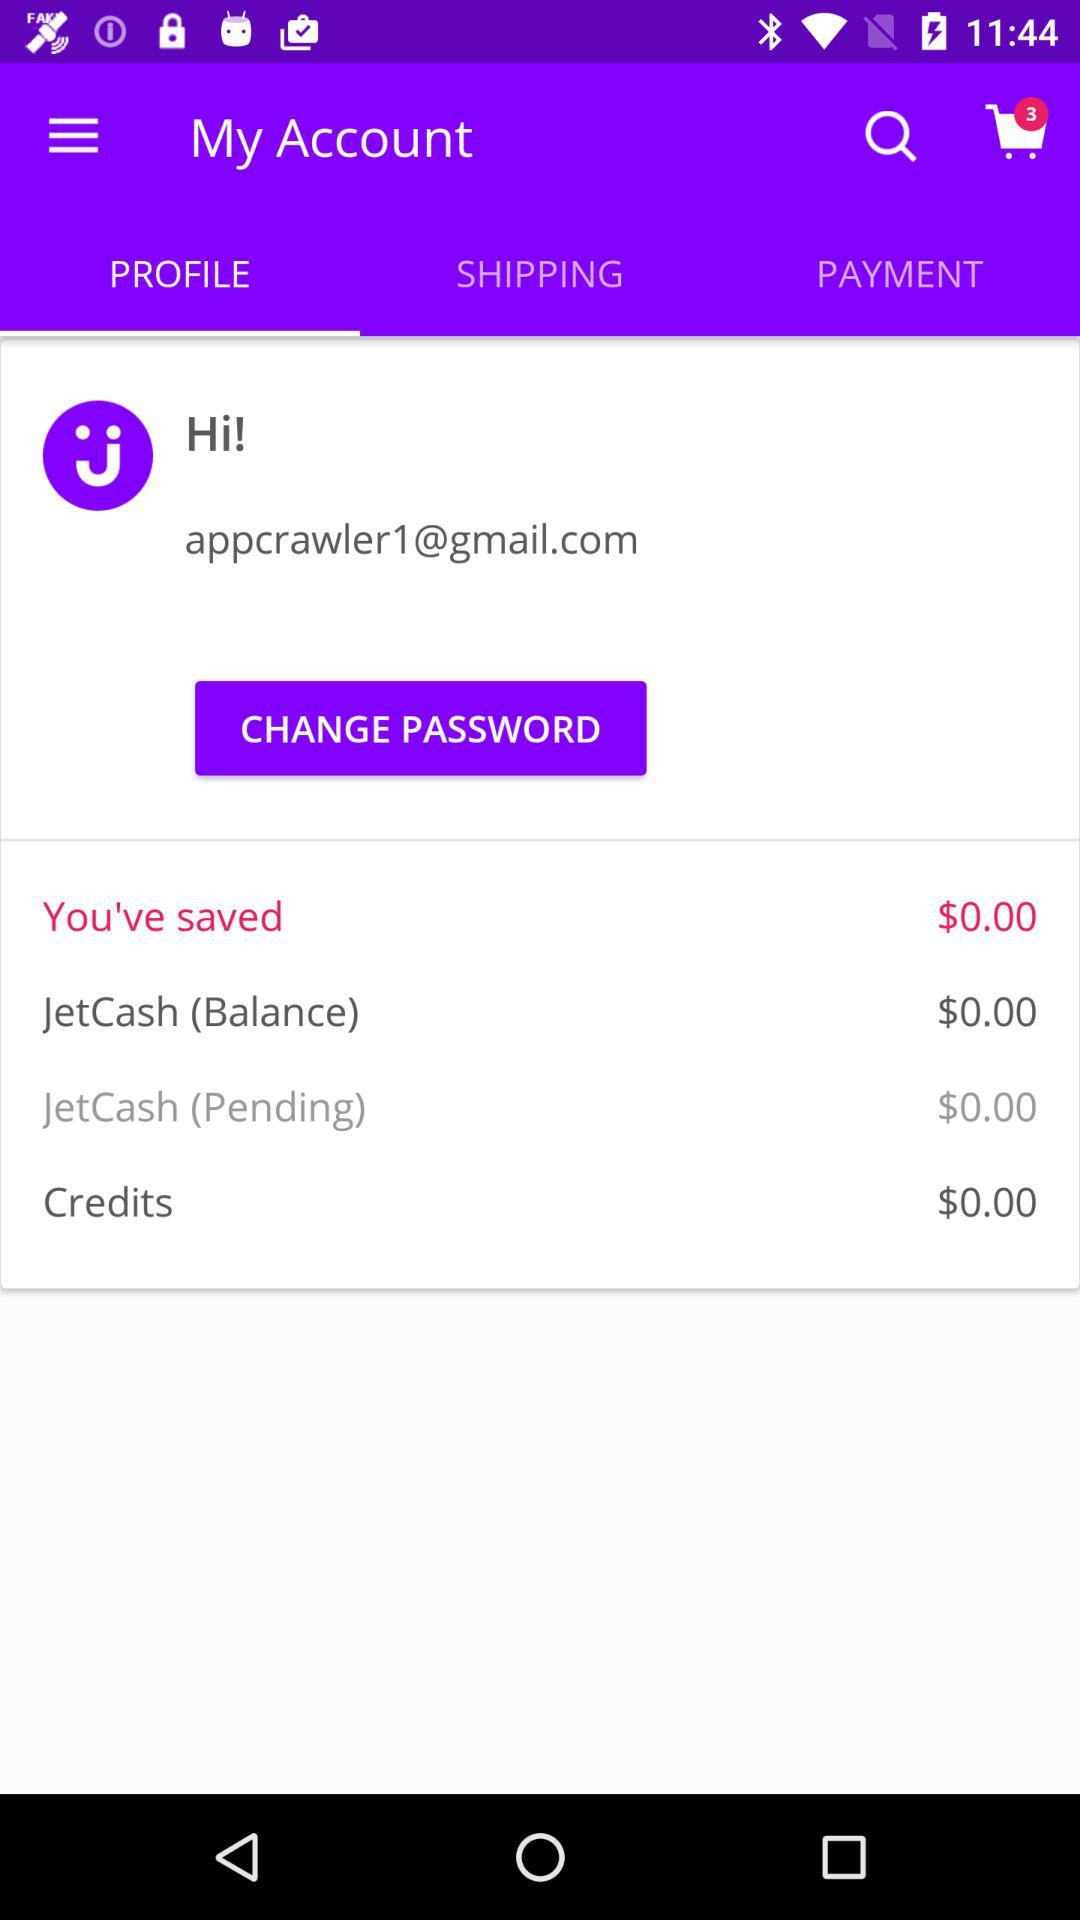What is the selected tab? The selected tab is "PROFILE". 